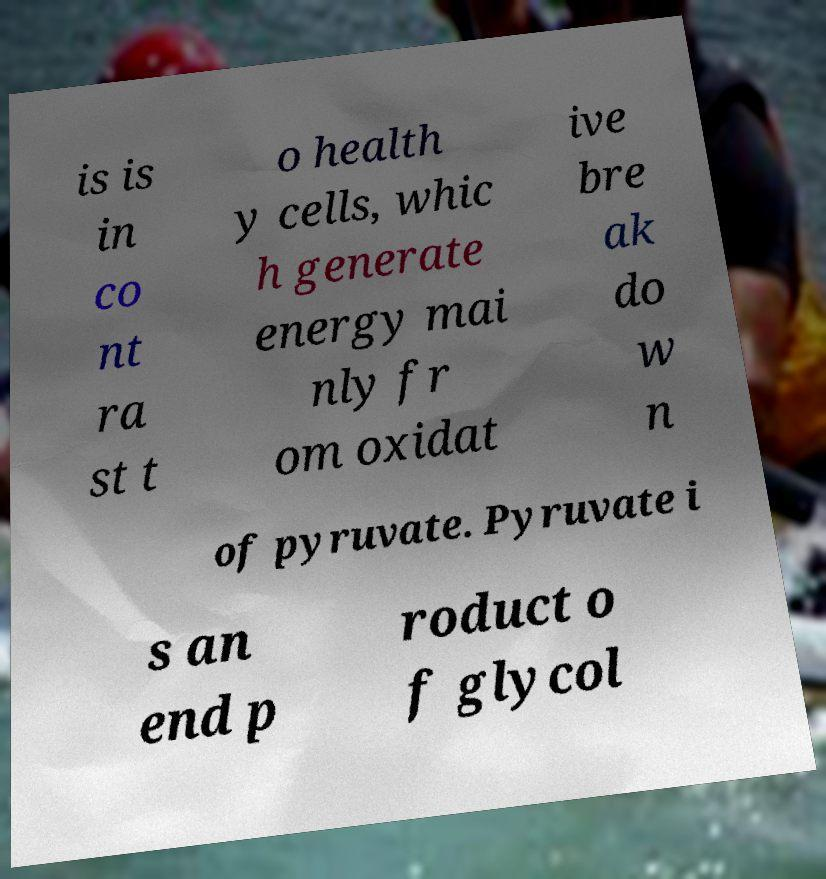What messages or text are displayed in this image? I need them in a readable, typed format. is is in co nt ra st t o health y cells, whic h generate energy mai nly fr om oxidat ive bre ak do w n of pyruvate. Pyruvate i s an end p roduct o f glycol 